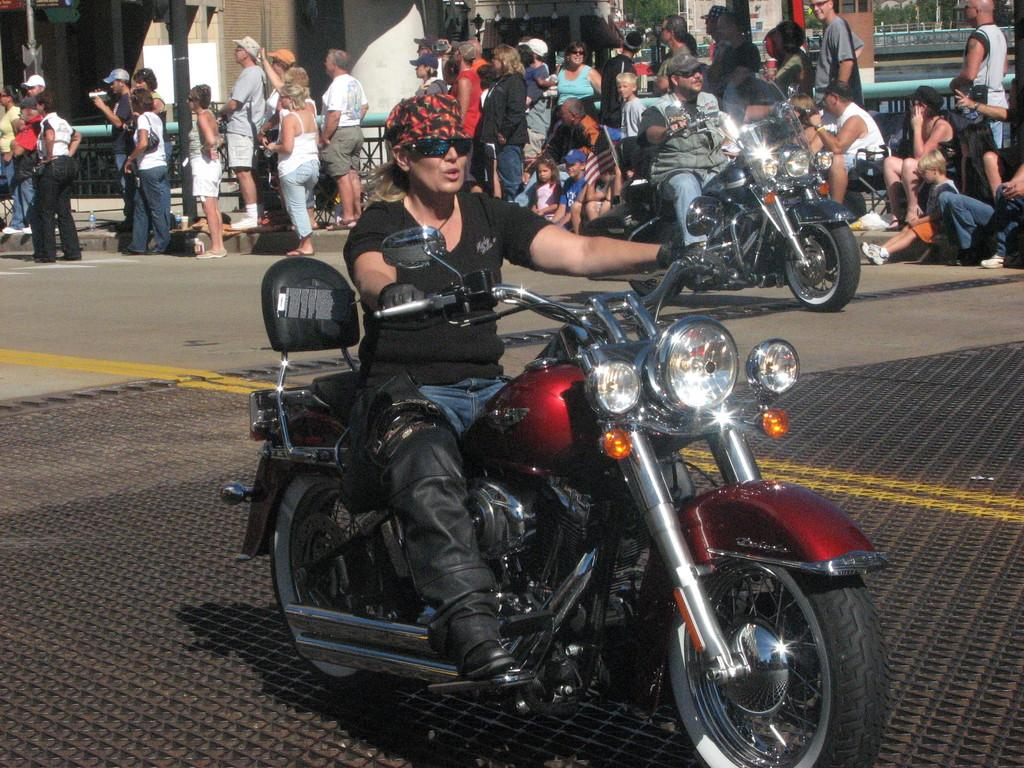What are the two people in the image doing? The two people are sitting on motorcycles in the image. How are the motorcycles positioned in the image? The motorcycles are on the ground in the image. What can be seen in the background of the image? There is a group of people and trees in the background of the image, along with some objects. What color are the legs of the rose in the image? There is no rose present in the image, and therefore no legs or color to describe. 